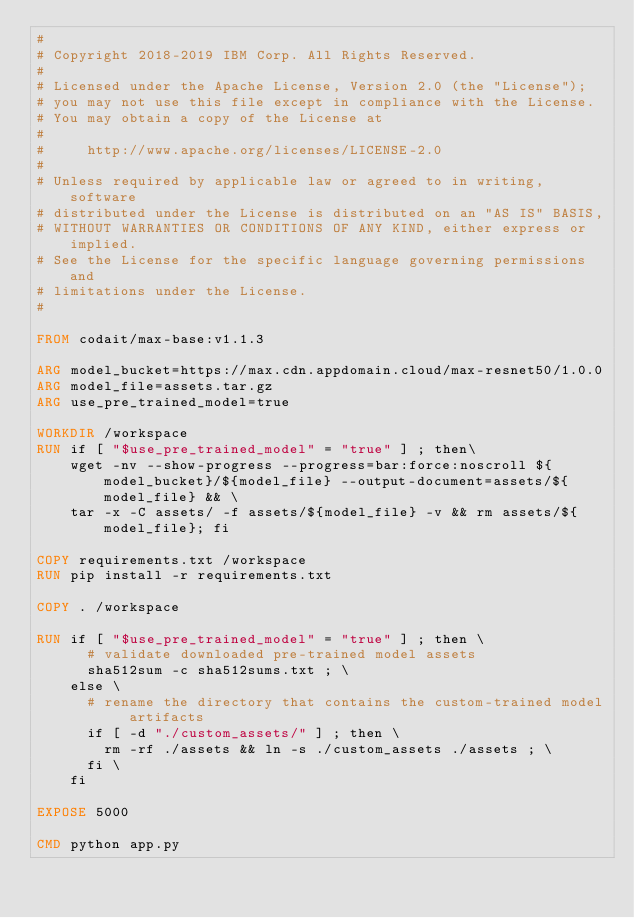<code> <loc_0><loc_0><loc_500><loc_500><_Dockerfile_>#
# Copyright 2018-2019 IBM Corp. All Rights Reserved.
#
# Licensed under the Apache License, Version 2.0 (the "License");
# you may not use this file except in compliance with the License.
# You may obtain a copy of the License at
#
#     http://www.apache.org/licenses/LICENSE-2.0
#
# Unless required by applicable law or agreed to in writing, software
# distributed under the License is distributed on an "AS IS" BASIS,
# WITHOUT WARRANTIES OR CONDITIONS OF ANY KIND, either express or implied.
# See the License for the specific language governing permissions and
# limitations under the License.
#

FROM codait/max-base:v1.1.3

ARG model_bucket=https://max.cdn.appdomain.cloud/max-resnet50/1.0.0
ARG model_file=assets.tar.gz
ARG use_pre_trained_model=true

WORKDIR /workspace
RUN if [ "$use_pre_trained_model" = "true" ] ; then\
    wget -nv --show-progress --progress=bar:force:noscroll ${model_bucket}/${model_file} --output-document=assets/${model_file} && \
    tar -x -C assets/ -f assets/${model_file} -v && rm assets/${model_file}; fi

COPY requirements.txt /workspace
RUN pip install -r requirements.txt

COPY . /workspace

RUN if [ "$use_pre_trained_model" = "true" ] ; then \
      # validate downloaded pre-trained model assets
      sha512sum -c sha512sums.txt ; \
    else \
      # rename the directory that contains the custom-trained model artifacts
      if [ -d "./custom_assets/" ] ; then \
        rm -rf ./assets && ln -s ./custom_assets ./assets ; \
      fi \
    fi

EXPOSE 5000

CMD python app.py

</code> 